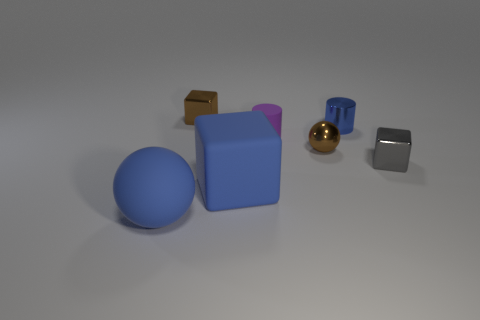The ball that is to the right of the small metallic block that is on the left side of the brown object in front of the small purple object is what color?
Your response must be concise. Brown. The other cube that is the same size as the brown metallic block is what color?
Provide a short and direct response. Gray. There is a large blue matte object that is to the right of the blue matte object that is on the left side of the small metal cube that is behind the tiny gray thing; what shape is it?
Your response must be concise. Cube. What is the shape of the metal object that is the same color as the matte cube?
Offer a terse response. Cylinder. What number of things are rubber cylinders or tiny metallic things that are on the left side of the small blue shiny object?
Make the answer very short. 3. Does the block behind the purple object have the same size as the tiny matte object?
Your answer should be very brief. Yes. There is a small block that is behind the small gray shiny cube; what is it made of?
Provide a short and direct response. Metal. Are there an equal number of matte objects that are to the right of the tiny purple cylinder and rubber cylinders to the right of the blue shiny cylinder?
Offer a very short reply. Yes. What color is the other object that is the same shape as the tiny matte thing?
Give a very brief answer. Blue. Is there any other thing that is the same color as the large matte sphere?
Offer a terse response. Yes. 